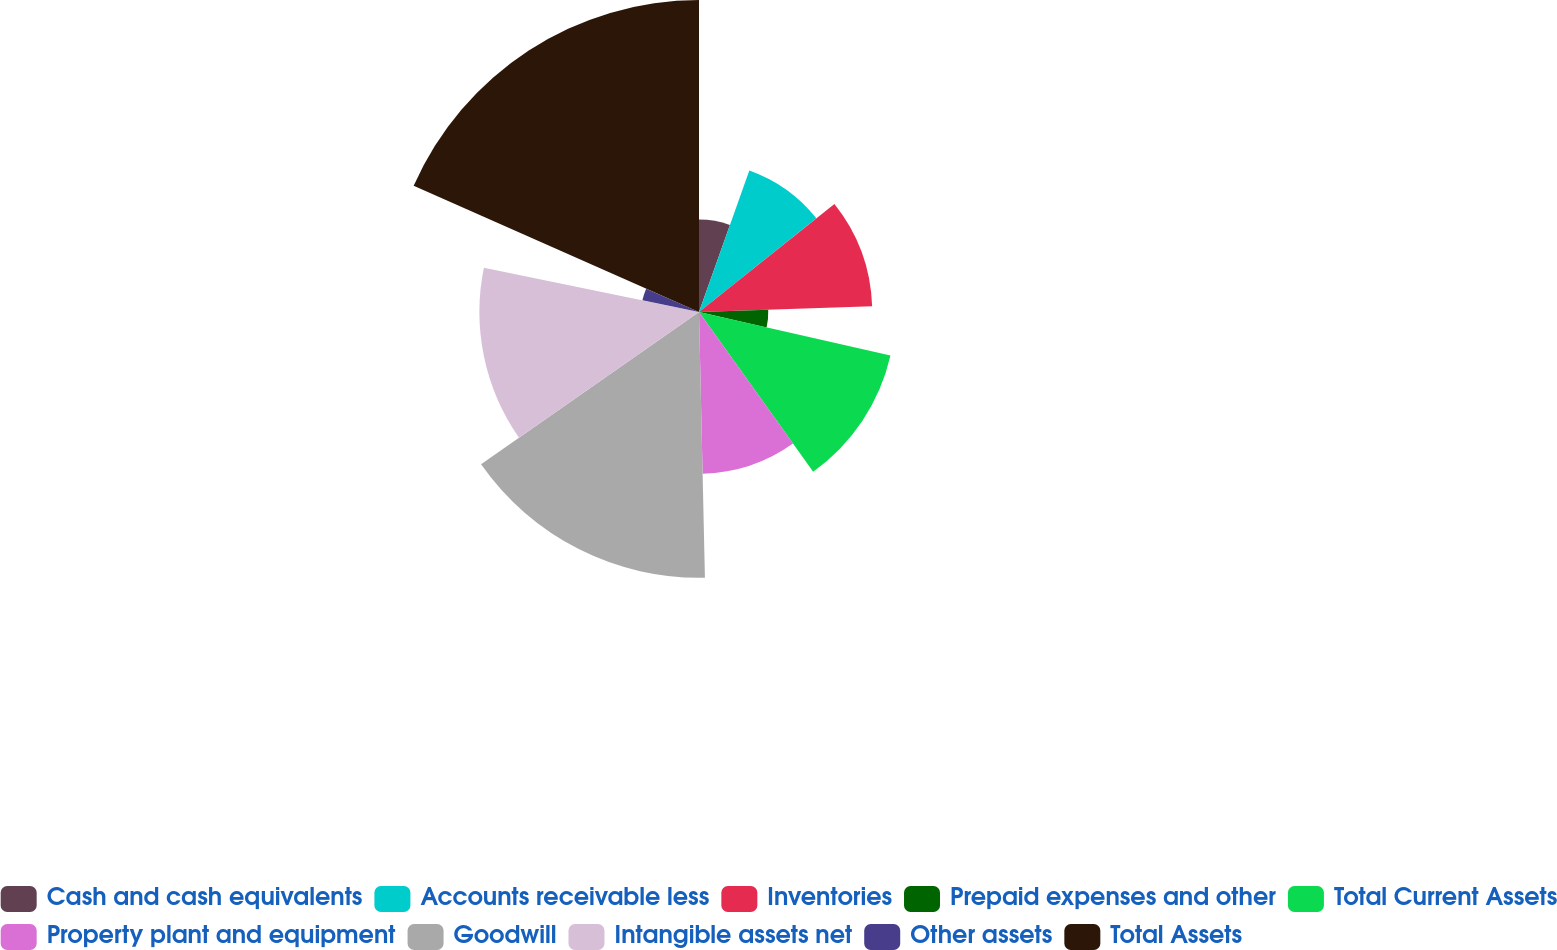Convert chart to OTSL. <chart><loc_0><loc_0><loc_500><loc_500><pie_chart><fcel>Cash and cash equivalents<fcel>Accounts receivable less<fcel>Inventories<fcel>Prepaid expenses and other<fcel>Total Current Assets<fcel>Property plant and equipment<fcel>Goodwill<fcel>Intangible assets net<fcel>Other assets<fcel>Total Assets<nl><fcel>5.44%<fcel>8.84%<fcel>10.2%<fcel>4.08%<fcel>11.56%<fcel>9.52%<fcel>15.65%<fcel>12.93%<fcel>3.4%<fcel>18.37%<nl></chart> 